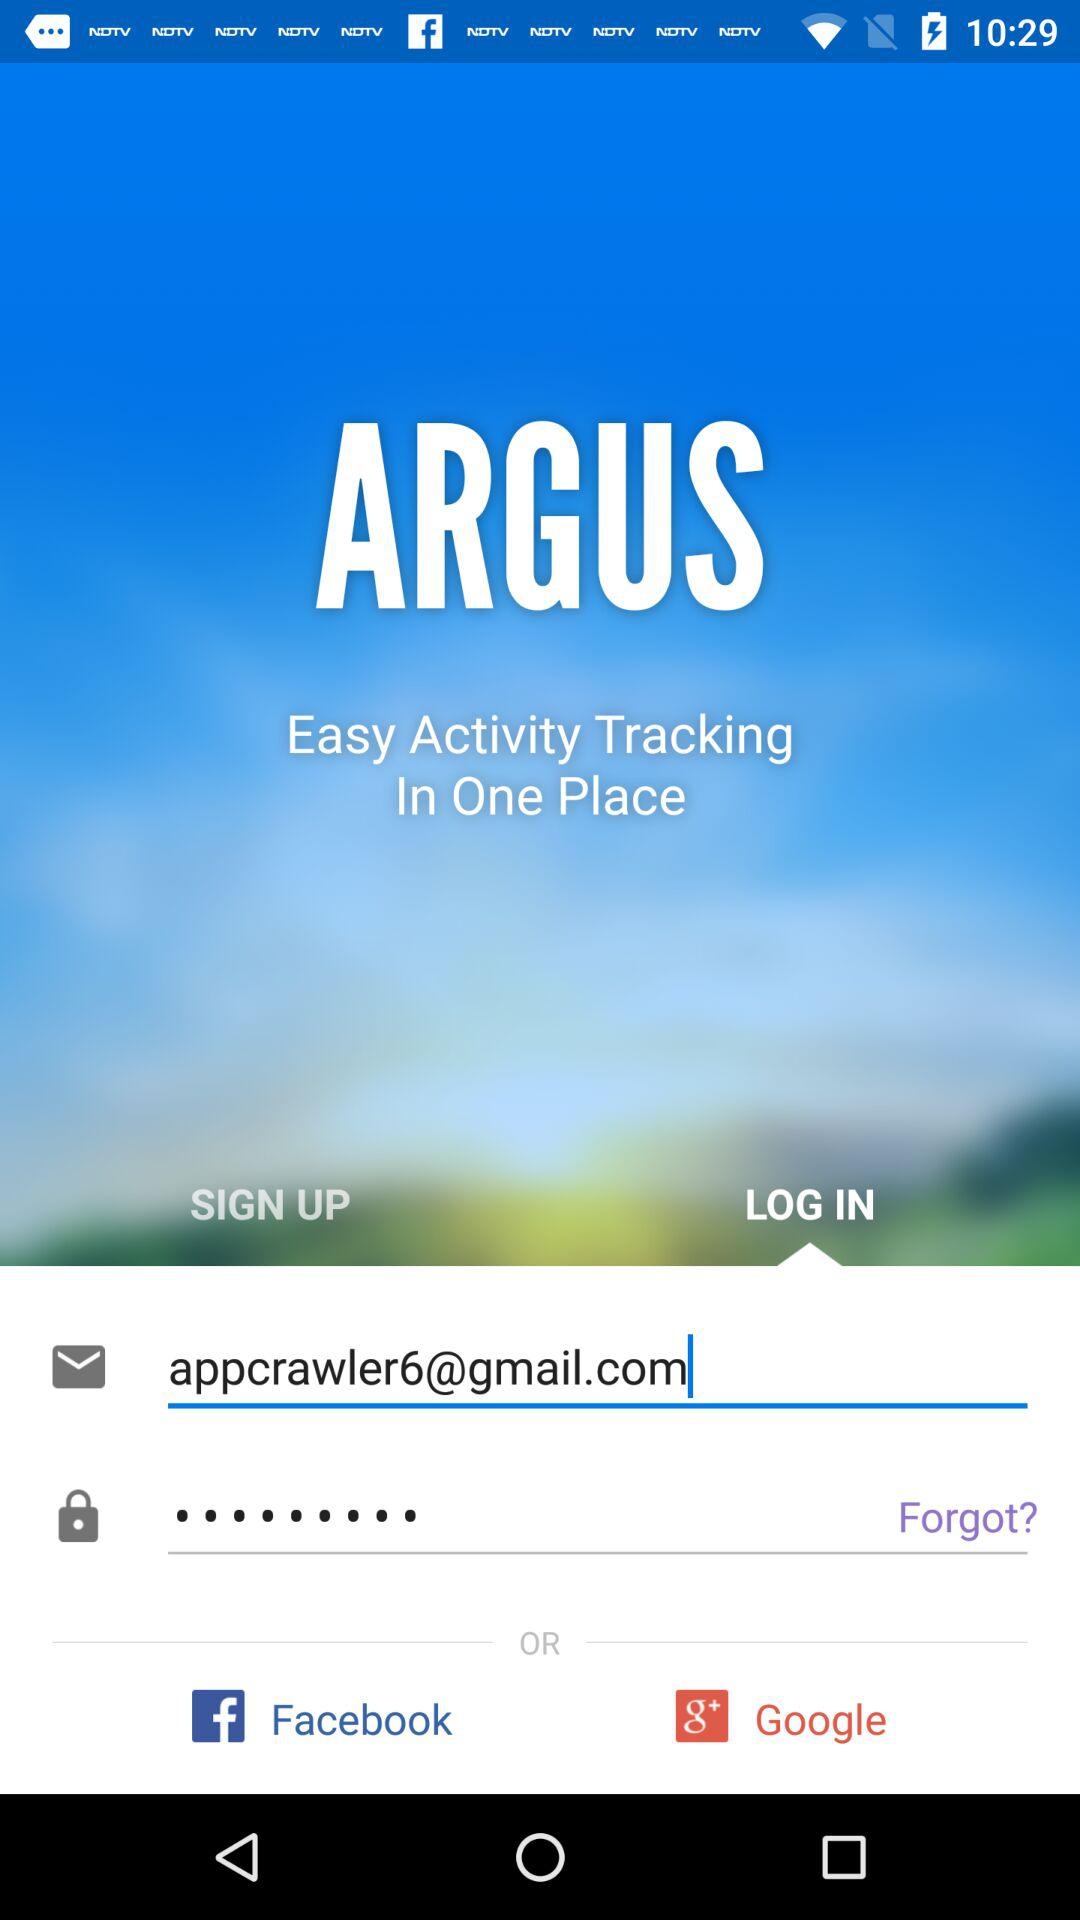What is the application name? The application name is "ARGUS". 